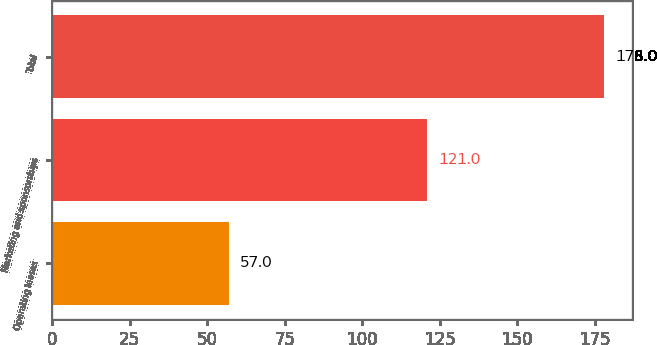<chart> <loc_0><loc_0><loc_500><loc_500><bar_chart><fcel>Operating leases<fcel>Marketing and sponsorships<fcel>Total<nl><fcel>57<fcel>121<fcel>178<nl></chart> 